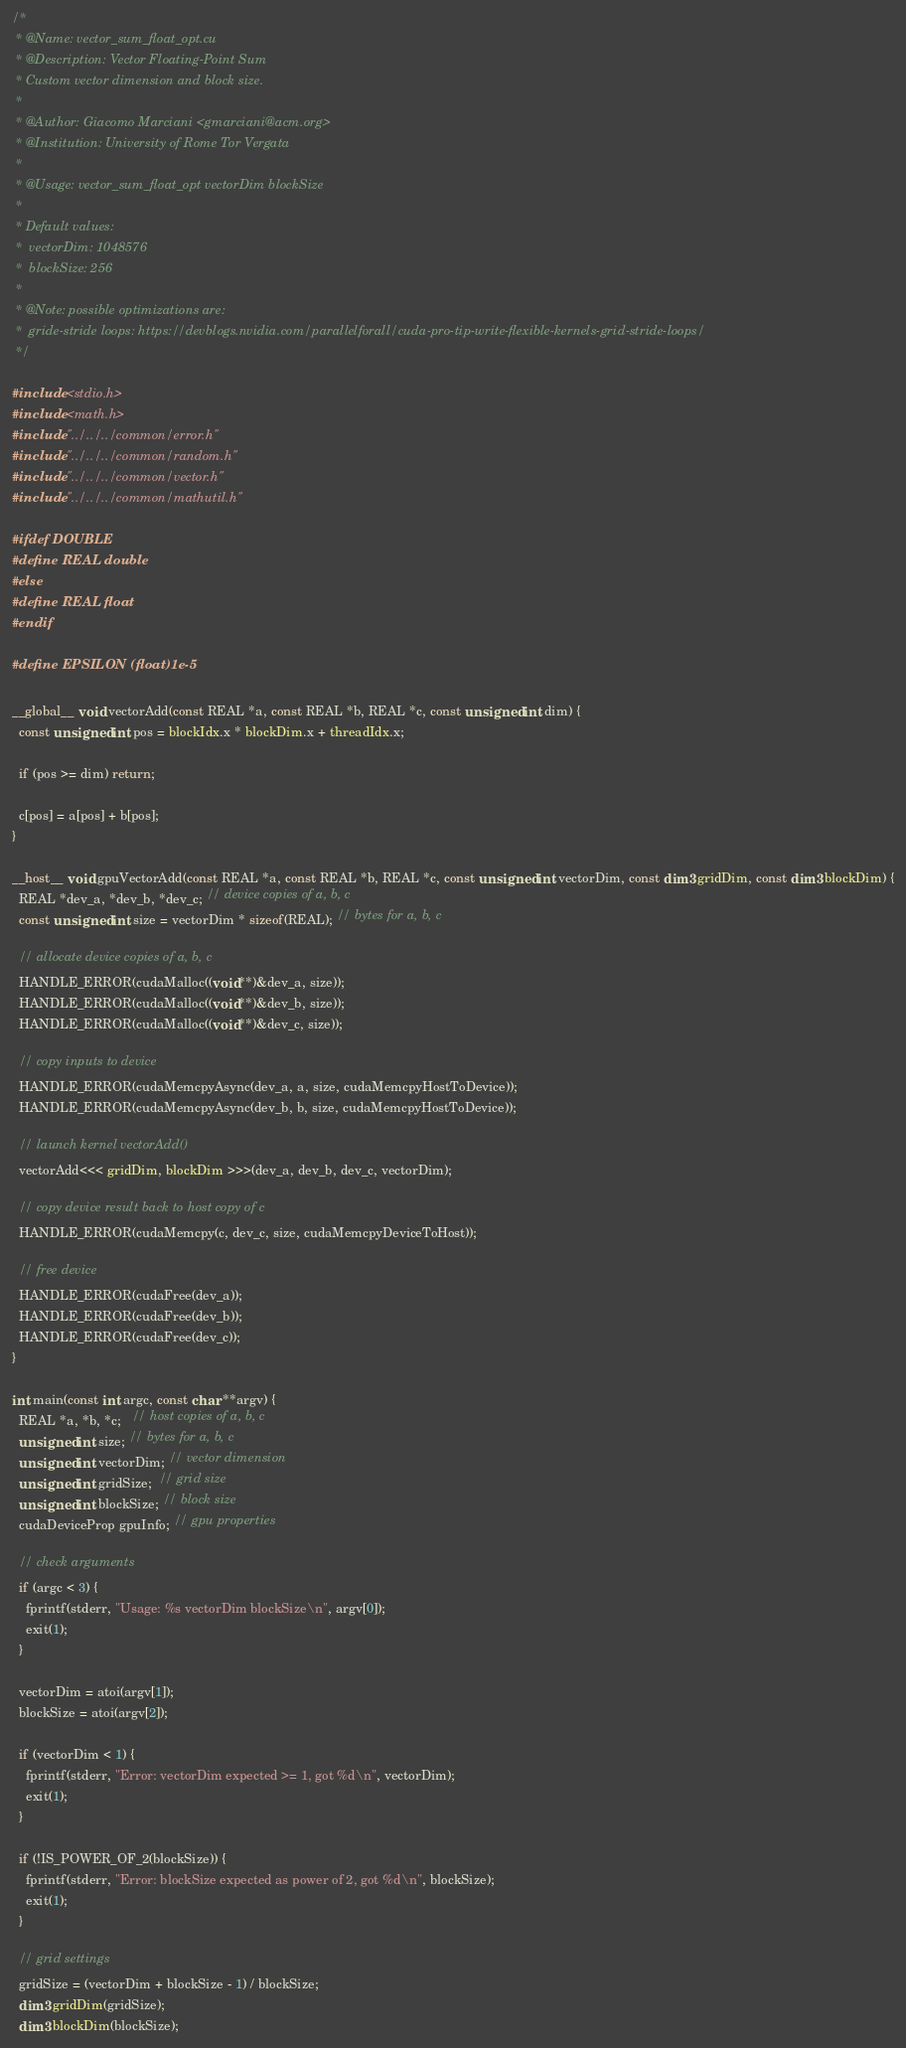Convert code to text. <code><loc_0><loc_0><loc_500><loc_500><_Cuda_>/*
 * @Name: vector_sum_float_opt.cu
 * @Description: Vector Floating-Point Sum
 * Custom vector dimension and block size.
 *
 * @Author: Giacomo Marciani <gmarciani@acm.org>
 * @Institution: University of Rome Tor Vergata
 *
 * @Usage: vector_sum_float_opt vectorDim blockSize
 *
 * Default values:
 *  vectorDim: 1048576
 *  blockSize: 256
 *
 * @Note: possible optimizations are:
 *  gride-stride loops: https://devblogs.nvidia.com/parallelforall/cuda-pro-tip-write-flexible-kernels-grid-stride-loops/
 */

#include <stdio.h>
#include <math.h>
#include "../../../common/error.h"
#include "../../../common/random.h"
#include "../../../common/vector.h"
#include "../../../common/mathutil.h"

#ifdef DOUBLE
#define REAL double
#else
#define REAL float
#endif

#define EPSILON (float)1e-5

__global__ void vectorAdd(const REAL *a, const REAL *b, REAL *c, const unsigned int dim) {
  const unsigned int pos = blockIdx.x * blockDim.x + threadIdx.x;

  if (pos >= dim) return;

  c[pos] = a[pos] + b[pos];
}

__host__ void gpuVectorAdd(const REAL *a, const REAL *b, REAL *c, const unsigned int vectorDim, const dim3 gridDim, const dim3 blockDim) {
  REAL *dev_a, *dev_b, *dev_c; // device copies of a, b, c
  const unsigned int size = vectorDim * sizeof(REAL); // bytes for a, b, c

  // allocate device copies of a, b, c
  HANDLE_ERROR(cudaMalloc((void**)&dev_a, size));
  HANDLE_ERROR(cudaMalloc((void**)&dev_b, size));
  HANDLE_ERROR(cudaMalloc((void**)&dev_c, size));

  // copy inputs to device
  HANDLE_ERROR(cudaMemcpyAsync(dev_a, a, size, cudaMemcpyHostToDevice));
  HANDLE_ERROR(cudaMemcpyAsync(dev_b, b, size, cudaMemcpyHostToDevice));

  // launch kernel vectorAdd()
  vectorAdd<<< gridDim, blockDim >>>(dev_a, dev_b, dev_c, vectorDim);

  // copy device result back to host copy of c
  HANDLE_ERROR(cudaMemcpy(c, dev_c, size, cudaMemcpyDeviceToHost));

  // free device
  HANDLE_ERROR(cudaFree(dev_a));
  HANDLE_ERROR(cudaFree(dev_b));
  HANDLE_ERROR(cudaFree(dev_c));
}

int main(const int argc, const char **argv) {
  REAL *a, *b, *c;   // host copies of a, b, c
  unsigned int size; // bytes for a, b, c
  unsigned int vectorDim; // vector dimension
  unsigned int gridSize;  // grid size
  unsigned int blockSize; // block size
  cudaDeviceProp gpuInfo; // gpu properties

  // check arguments
  if (argc < 3) {
    fprintf(stderr, "Usage: %s vectorDim blockSize\n", argv[0]);
    exit(1);
  }

  vectorDim = atoi(argv[1]);
  blockSize = atoi(argv[2]);

  if (vectorDim < 1) {
    fprintf(stderr, "Error: vectorDim expected >= 1, got %d\n", vectorDim);
    exit(1);
  }

  if (!IS_POWER_OF_2(blockSize)) {
    fprintf(stderr, "Error: blockSize expected as power of 2, got %d\n", blockSize);
    exit(1);
  }

  // grid settings
  gridSize = (vectorDim + blockSize - 1) / blockSize;
  dim3 gridDim(gridSize);
  dim3 blockDim(blockSize);
</code> 